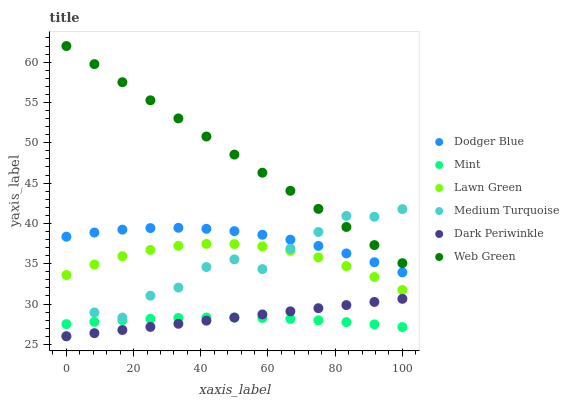Does Mint have the minimum area under the curve?
Answer yes or no. Yes. Does Web Green have the maximum area under the curve?
Answer yes or no. Yes. Does Dodger Blue have the minimum area under the curve?
Answer yes or no. No. Does Dodger Blue have the maximum area under the curve?
Answer yes or no. No. Is Dark Periwinkle the smoothest?
Answer yes or no. Yes. Is Medium Turquoise the roughest?
Answer yes or no. Yes. Is Web Green the smoothest?
Answer yes or no. No. Is Web Green the roughest?
Answer yes or no. No. Does Medium Turquoise have the lowest value?
Answer yes or no. Yes. Does Dodger Blue have the lowest value?
Answer yes or no. No. Does Web Green have the highest value?
Answer yes or no. Yes. Does Dodger Blue have the highest value?
Answer yes or no. No. Is Lawn Green less than Dodger Blue?
Answer yes or no. Yes. Is Web Green greater than Lawn Green?
Answer yes or no. Yes. Does Medium Turquoise intersect Dark Periwinkle?
Answer yes or no. Yes. Is Medium Turquoise less than Dark Periwinkle?
Answer yes or no. No. Is Medium Turquoise greater than Dark Periwinkle?
Answer yes or no. No. Does Lawn Green intersect Dodger Blue?
Answer yes or no. No. 